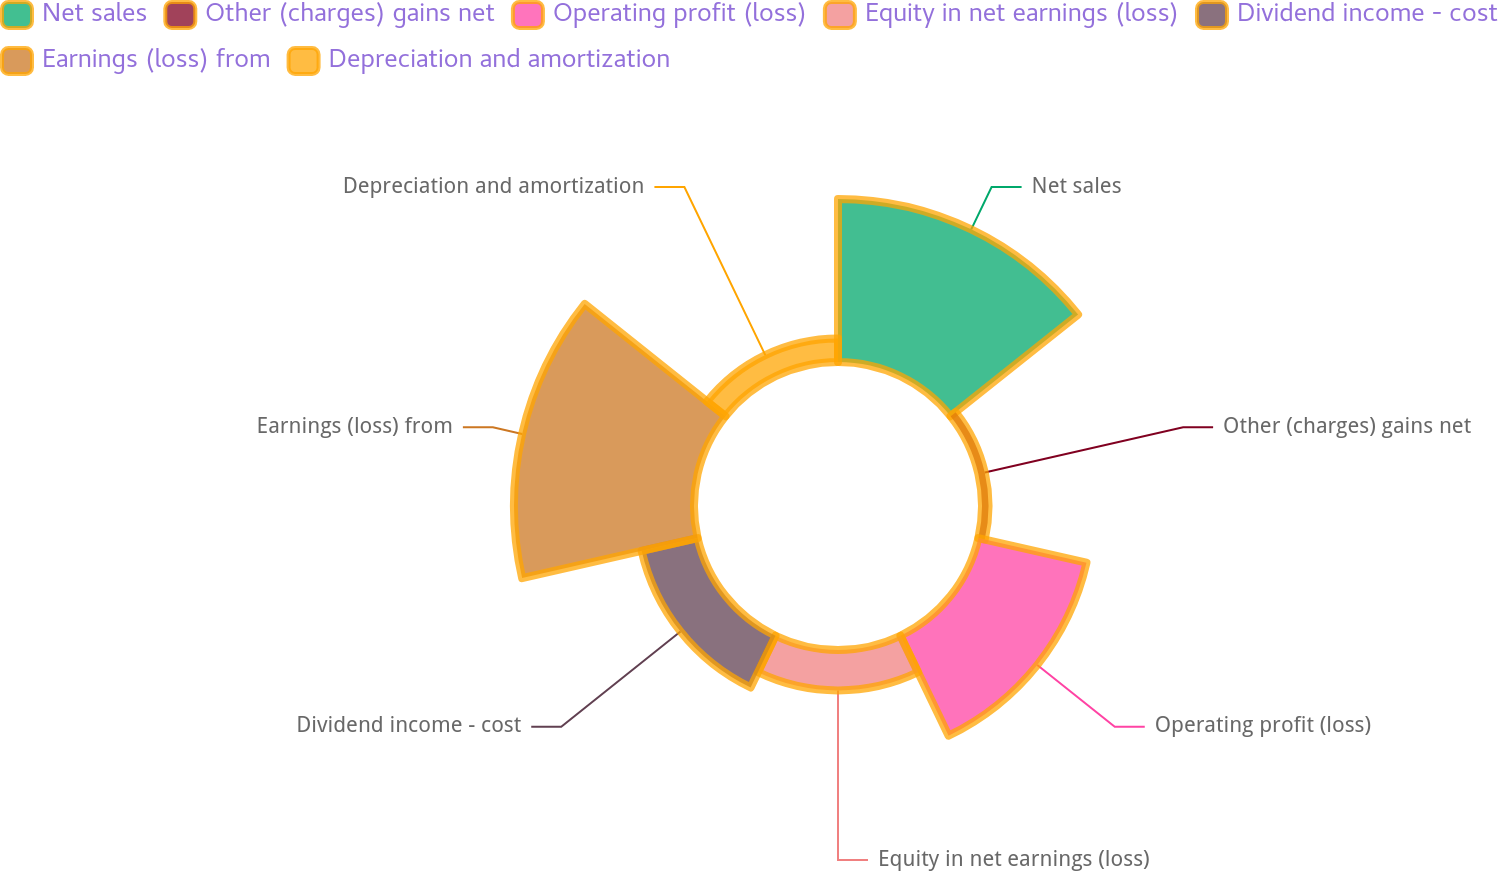Convert chart to OTSL. <chart><loc_0><loc_0><loc_500><loc_500><pie_chart><fcel>Net sales<fcel>Other (charges) gains net<fcel>Operating profit (loss)<fcel>Equity in net earnings (loss)<fcel>Dividend income - cost<fcel>Earnings (loss) from<fcel>Depreciation and amortization<nl><fcel>28.03%<fcel>1.12%<fcel>19.06%<fcel>6.95%<fcel>9.87%<fcel>30.94%<fcel>4.04%<nl></chart> 